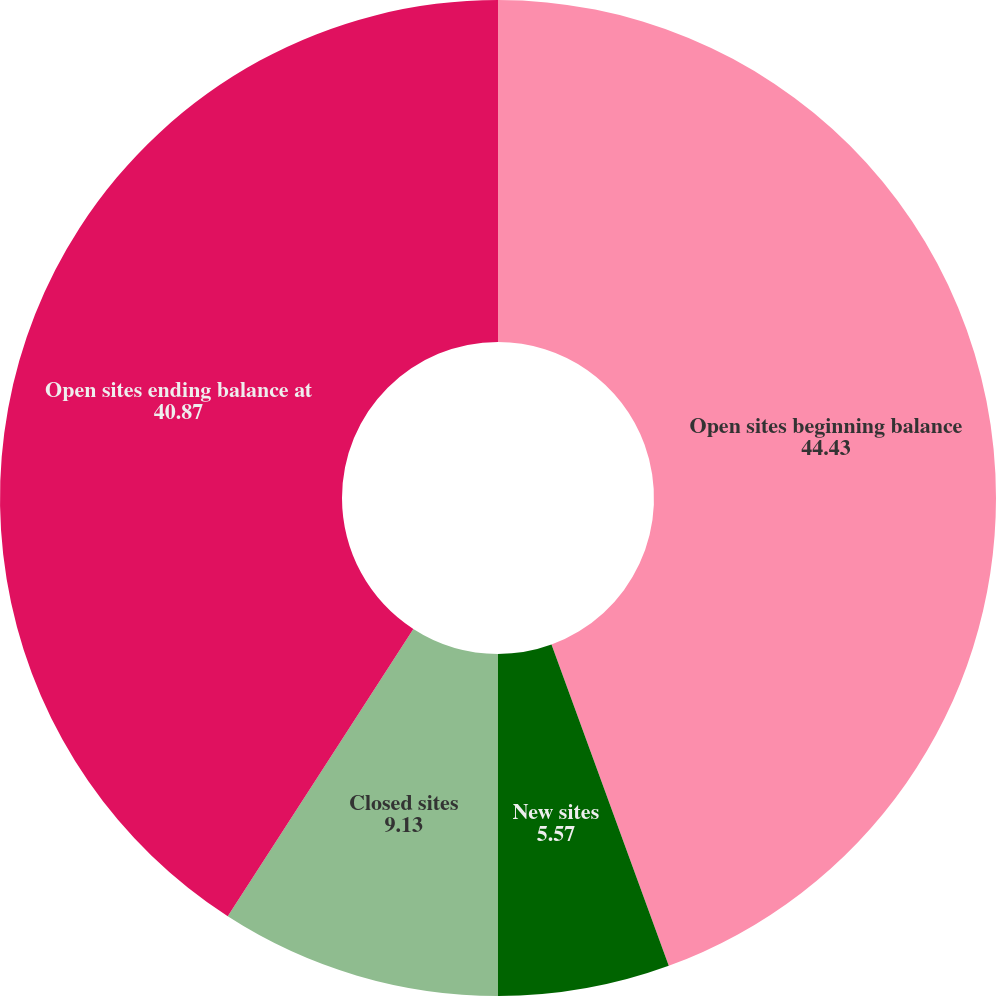Convert chart to OTSL. <chart><loc_0><loc_0><loc_500><loc_500><pie_chart><fcel>Open sites beginning balance<fcel>New sites<fcel>Closed sites<fcel>Open sites ending balance at<nl><fcel>44.43%<fcel>5.57%<fcel>9.13%<fcel>40.87%<nl></chart> 